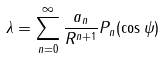Convert formula to latex. <formula><loc_0><loc_0><loc_500><loc_500>\lambda = \sum _ { n = 0 } ^ { \infty } \frac { a _ { n } } { R ^ { n + 1 } } P _ { n } ( \cos \psi )</formula> 